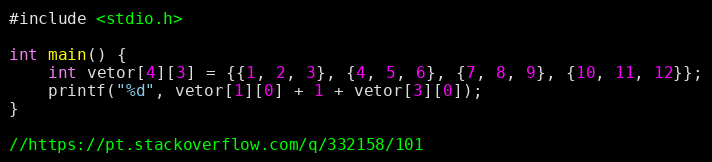<code> <loc_0><loc_0><loc_500><loc_500><_C_>#include <stdio.h>

int main() {
    int vetor[4][3] = {{1, 2, 3}, {4, 5, 6}, {7, 8, 9}, {10, 11, 12}};
    printf("%d", vetor[1][0] + 1 + vetor[3][0]);
}

//https://pt.stackoverflow.com/q/332158/101
</code> 